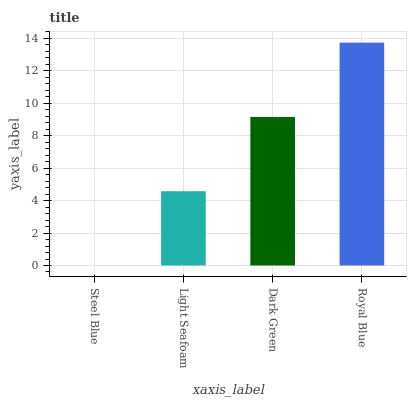Is Royal Blue the maximum?
Answer yes or no. Yes. Is Light Seafoam the minimum?
Answer yes or no. No. Is Light Seafoam the maximum?
Answer yes or no. No. Is Light Seafoam greater than Steel Blue?
Answer yes or no. Yes. Is Steel Blue less than Light Seafoam?
Answer yes or no. Yes. Is Steel Blue greater than Light Seafoam?
Answer yes or no. No. Is Light Seafoam less than Steel Blue?
Answer yes or no. No. Is Dark Green the high median?
Answer yes or no. Yes. Is Light Seafoam the low median?
Answer yes or no. Yes. Is Light Seafoam the high median?
Answer yes or no. No. Is Royal Blue the low median?
Answer yes or no. No. 